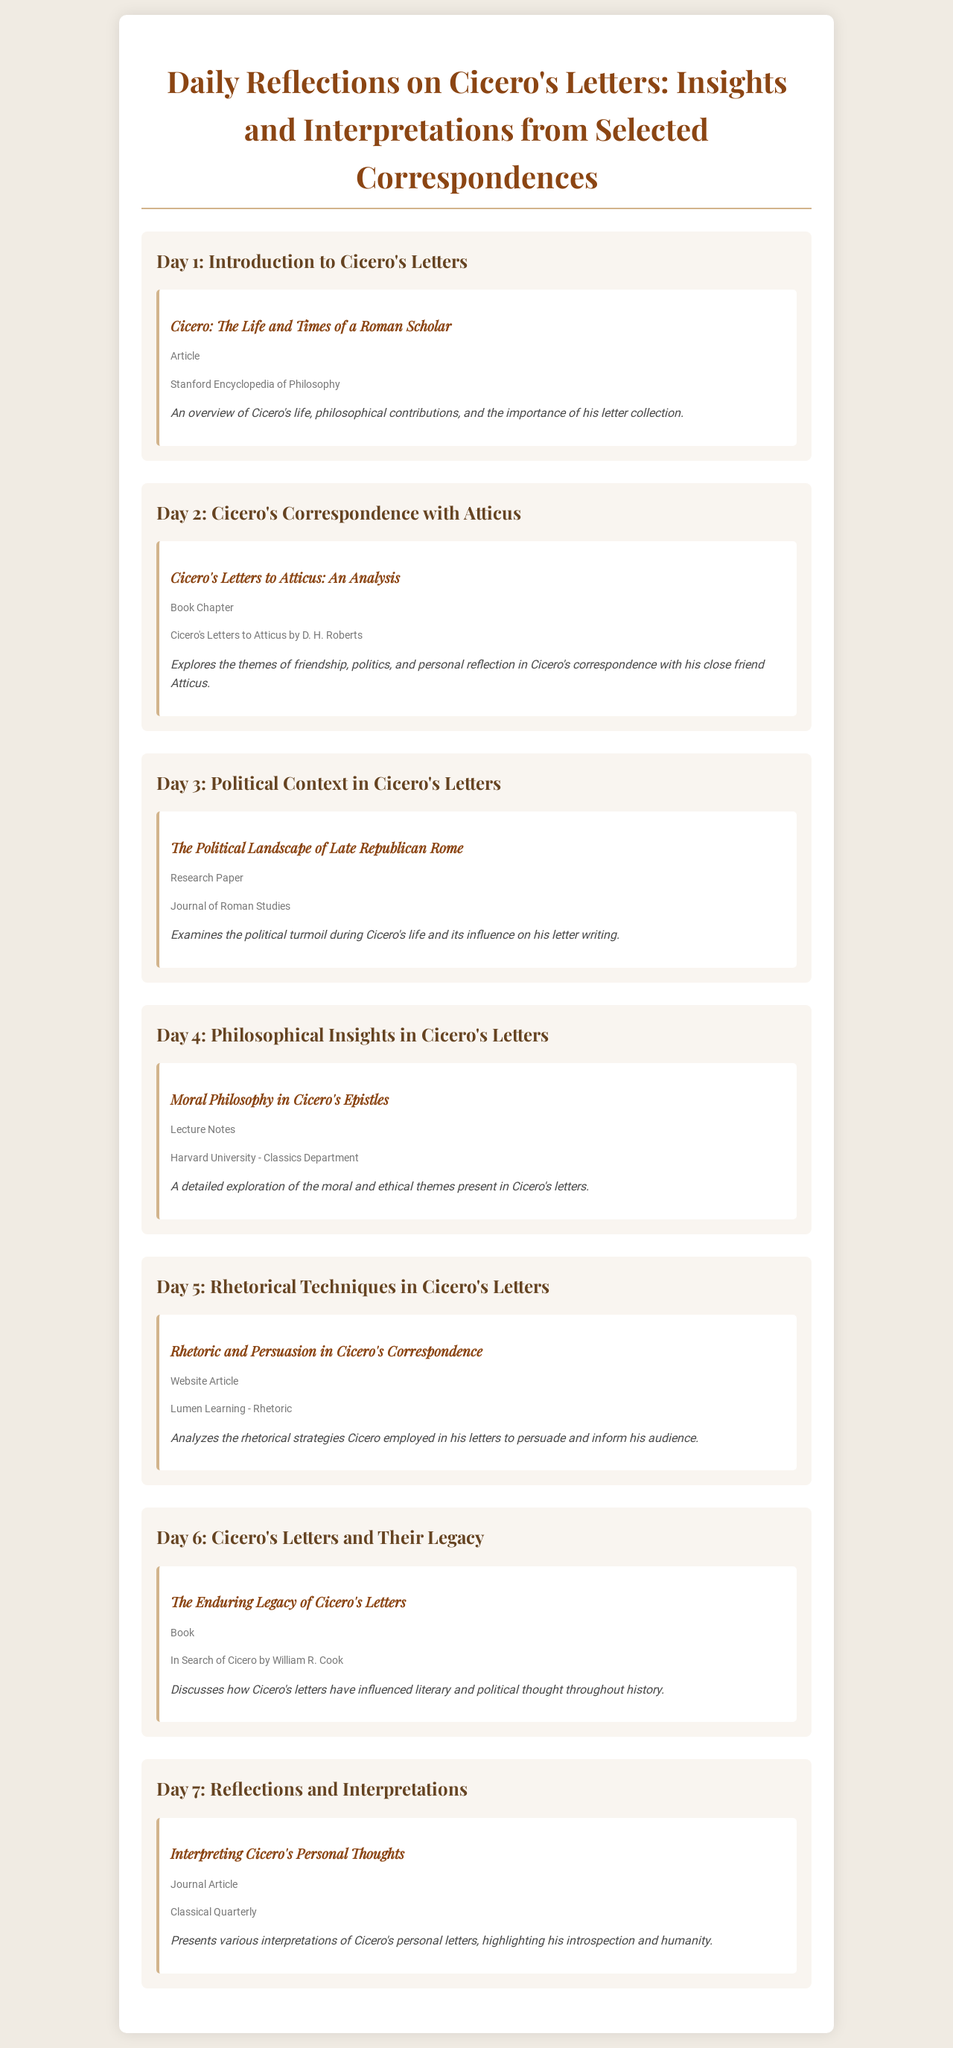What is the title of the document? The title of the document is prominently displayed at the top of the rendered page.
Answer: Daily Reflections on Cicero's Letters: Insights and Interpretations from Selected Correspondences How many days are covered in the reflections? Each daily reflection is clearly labeled and listed in the document, allowing us to count them.
Answer: 7 What is the source of the article on Cicero's life? The source of the article is mentioned in the material description for Day 1.
Answer: Stanford Encyclopedia of Philosophy What theme is explored in Cicero's correspondence with Atticus? The theme is specified in the description for Day 2, highlighting the content of the letters.
Answer: Friendship, politics, and personal reflection What type of material is presented on Day 4? Each day's material type is categorized, particularly in Day 4's description.
Answer: Lecture Notes Which book discusses Cicero's letters' legacy? The title of the book is included in Day 6's material description.
Answer: In Search of Cicero What publication features the political landscape analysis? The publication is noted in the source detail of Day 3's material.
Answer: Journal of Roman Studies 